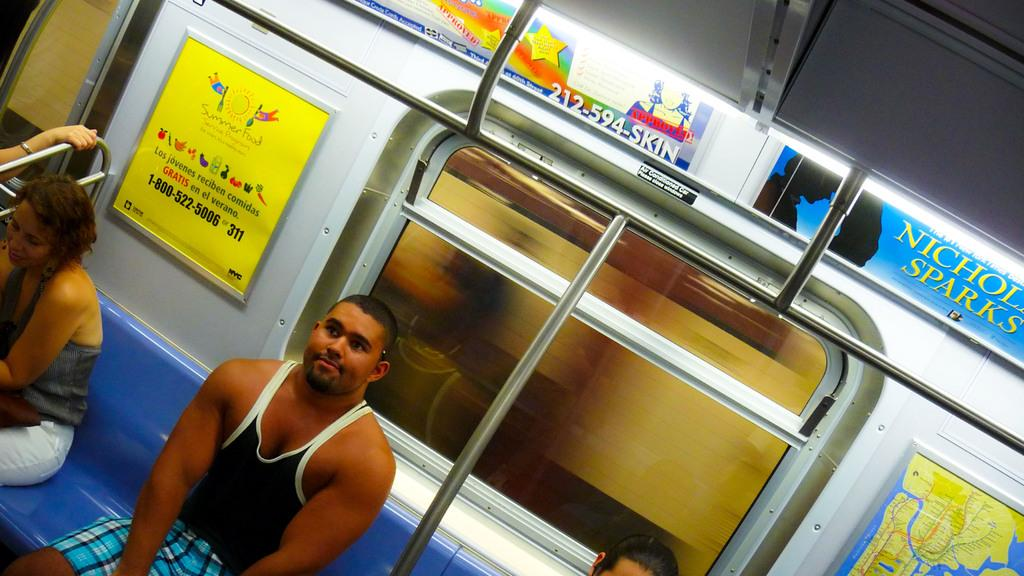Provide a one-sentence caption for the provided image. An ad for a Nicholas Sparks book is among other ads above the bus windows. 